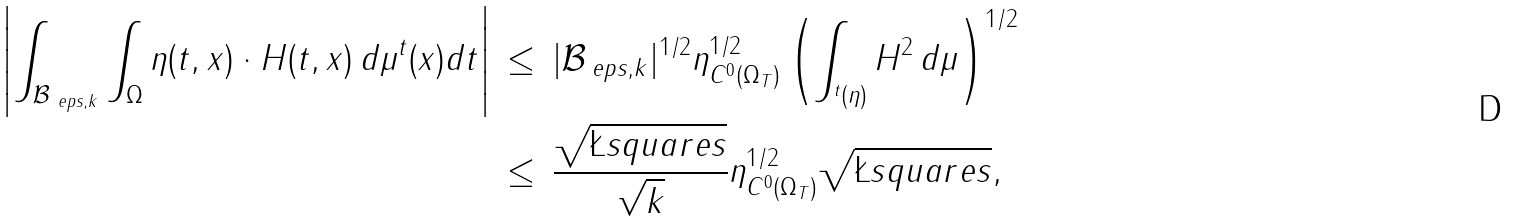<formula> <loc_0><loc_0><loc_500><loc_500>\left | \int _ { \mathcal { B } _ { \ e p s , k } } \int _ { \Omega } \eta ( t , x ) \cdot H ( t , x ) \, d \mu ^ { t } ( x ) d t \right | \, & \leq \, | \mathcal { B } _ { \ e p s , k } | ^ { 1 / 2 } \| \eta \| _ { C ^ { 0 } ( \Omega _ { T } ) } ^ { 1 / 2 } \left ( \int _ { ^ { t } ( \eta ) } H ^ { 2 } \, d \mu \right ) ^ { 1 / 2 } \\ & \leq \, \frac { \sqrt { \L s q u a r e s } } { \sqrt { k } } \| \eta \| _ { C ^ { 0 } ( \Omega _ { T } ) } ^ { 1 / 2 } \sqrt { \L s q u a r e s } ,</formula> 